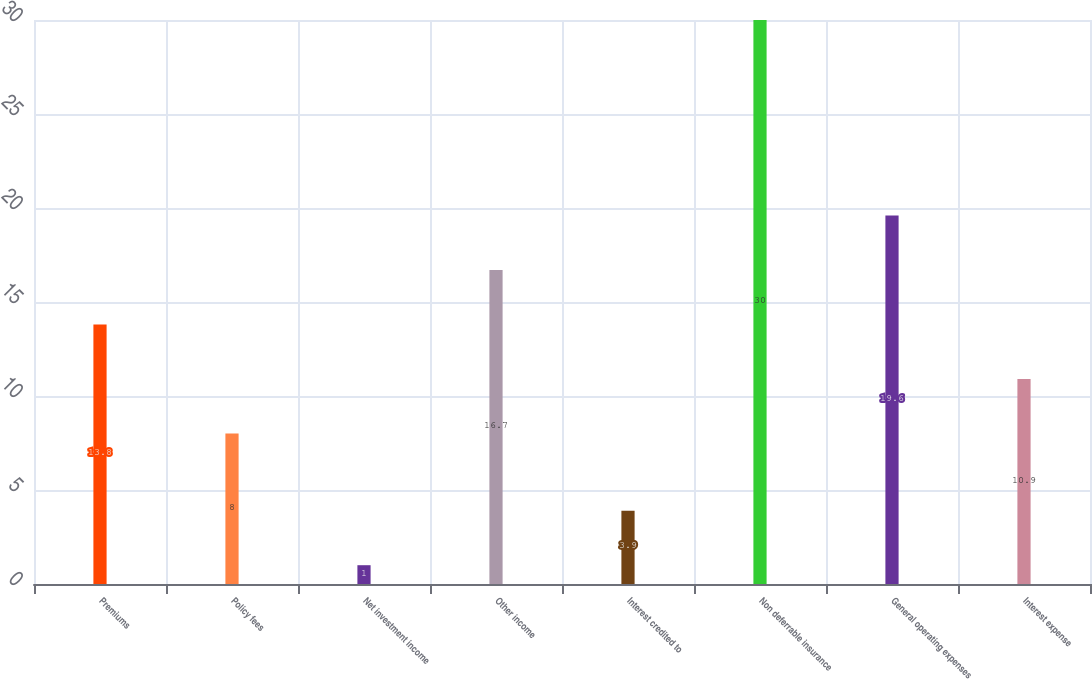Convert chart to OTSL. <chart><loc_0><loc_0><loc_500><loc_500><bar_chart><fcel>Premiums<fcel>Policy fees<fcel>Net investment income<fcel>Other income<fcel>Interest credited to<fcel>Non deferrable insurance<fcel>General operating expenses<fcel>Interest expense<nl><fcel>13.8<fcel>8<fcel>1<fcel>16.7<fcel>3.9<fcel>30<fcel>19.6<fcel>10.9<nl></chart> 